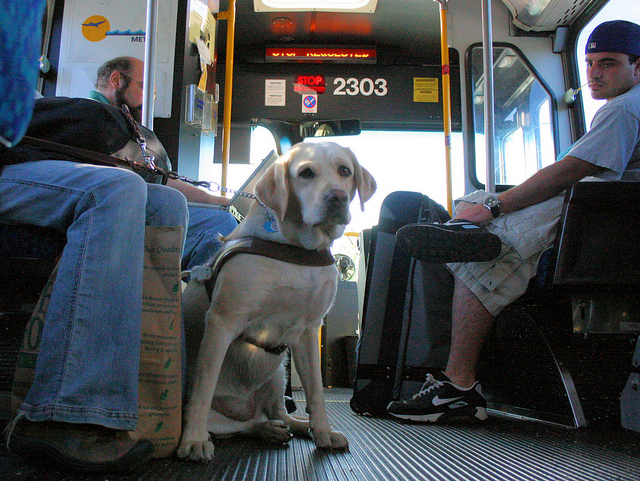Identify the text displayed in this image. 2303 STOP MET 9 